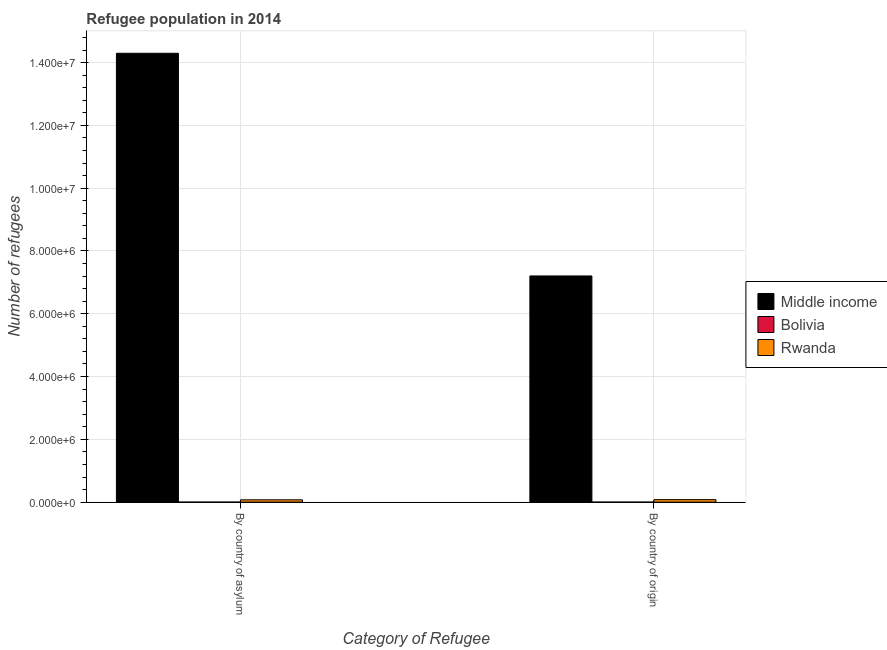How many different coloured bars are there?
Your response must be concise. 3. Are the number of bars per tick equal to the number of legend labels?
Provide a succinct answer. Yes. How many bars are there on the 1st tick from the right?
Provide a short and direct response. 3. What is the label of the 2nd group of bars from the left?
Offer a very short reply. By country of origin. What is the number of refugees by country of asylum in Rwanda?
Your response must be concise. 7.38e+04. Across all countries, what is the maximum number of refugees by country of origin?
Provide a succinct answer. 7.20e+06. Across all countries, what is the minimum number of refugees by country of asylum?
Your answer should be compact. 763. In which country was the number of refugees by country of origin minimum?
Your answer should be very brief. Bolivia. What is the total number of refugees by country of asylum in the graph?
Give a very brief answer. 1.44e+07. What is the difference between the number of refugees by country of origin in Bolivia and that in Middle income?
Your answer should be compact. -7.20e+06. What is the difference between the number of refugees by country of origin in Middle income and the number of refugees by country of asylum in Rwanda?
Keep it short and to the point. 7.13e+06. What is the average number of refugees by country of origin per country?
Ensure brevity in your answer.  2.43e+06. What is the difference between the number of refugees by country of asylum and number of refugees by country of origin in Bolivia?
Provide a short and direct response. 164. What is the ratio of the number of refugees by country of origin in Rwanda to that in Bolivia?
Give a very brief answer. 132.57. What does the 2nd bar from the left in By country of asylum represents?
Offer a terse response. Bolivia. How many bars are there?
Ensure brevity in your answer.  6. Are all the bars in the graph horizontal?
Your response must be concise. No. How many countries are there in the graph?
Make the answer very short. 3. What is the difference between two consecutive major ticks on the Y-axis?
Offer a very short reply. 2.00e+06. Does the graph contain grids?
Keep it short and to the point. Yes. How many legend labels are there?
Offer a terse response. 3. How are the legend labels stacked?
Your answer should be compact. Vertical. What is the title of the graph?
Keep it short and to the point. Refugee population in 2014. Does "Korea (Democratic)" appear as one of the legend labels in the graph?
Make the answer very short. No. What is the label or title of the X-axis?
Provide a succinct answer. Category of Refugee. What is the label or title of the Y-axis?
Offer a terse response. Number of refugees. What is the Number of refugees of Middle income in By country of asylum?
Provide a short and direct response. 1.43e+07. What is the Number of refugees in Bolivia in By country of asylum?
Provide a succinct answer. 763. What is the Number of refugees in Rwanda in By country of asylum?
Offer a very short reply. 7.38e+04. What is the Number of refugees in Middle income in By country of origin?
Offer a very short reply. 7.20e+06. What is the Number of refugees in Bolivia in By country of origin?
Your response must be concise. 599. What is the Number of refugees in Rwanda in By country of origin?
Your answer should be very brief. 7.94e+04. Across all Category of Refugee, what is the maximum Number of refugees in Middle income?
Offer a terse response. 1.43e+07. Across all Category of Refugee, what is the maximum Number of refugees in Bolivia?
Your answer should be very brief. 763. Across all Category of Refugee, what is the maximum Number of refugees in Rwanda?
Your response must be concise. 7.94e+04. Across all Category of Refugee, what is the minimum Number of refugees in Middle income?
Provide a succinct answer. 7.20e+06. Across all Category of Refugee, what is the minimum Number of refugees in Bolivia?
Your answer should be compact. 599. Across all Category of Refugee, what is the minimum Number of refugees in Rwanda?
Provide a short and direct response. 7.38e+04. What is the total Number of refugees of Middle income in the graph?
Make the answer very short. 2.15e+07. What is the total Number of refugees in Bolivia in the graph?
Keep it short and to the point. 1362. What is the total Number of refugees of Rwanda in the graph?
Provide a short and direct response. 1.53e+05. What is the difference between the Number of refugees of Middle income in By country of asylum and that in By country of origin?
Provide a succinct answer. 7.09e+06. What is the difference between the Number of refugees of Bolivia in By country of asylum and that in By country of origin?
Your answer should be very brief. 164. What is the difference between the Number of refugees of Rwanda in By country of asylum and that in By country of origin?
Offer a very short reply. -5591. What is the difference between the Number of refugees of Middle income in By country of asylum and the Number of refugees of Bolivia in By country of origin?
Your answer should be compact. 1.43e+07. What is the difference between the Number of refugees in Middle income in By country of asylum and the Number of refugees in Rwanda in By country of origin?
Give a very brief answer. 1.42e+07. What is the difference between the Number of refugees of Bolivia in By country of asylum and the Number of refugees of Rwanda in By country of origin?
Offer a terse response. -7.86e+04. What is the average Number of refugees of Middle income per Category of Refugee?
Keep it short and to the point. 1.08e+07. What is the average Number of refugees of Bolivia per Category of Refugee?
Make the answer very short. 681. What is the average Number of refugees in Rwanda per Category of Refugee?
Offer a very short reply. 7.66e+04. What is the difference between the Number of refugees of Middle income and Number of refugees of Bolivia in By country of asylum?
Give a very brief answer. 1.43e+07. What is the difference between the Number of refugees in Middle income and Number of refugees in Rwanda in By country of asylum?
Give a very brief answer. 1.42e+07. What is the difference between the Number of refugees in Bolivia and Number of refugees in Rwanda in By country of asylum?
Ensure brevity in your answer.  -7.31e+04. What is the difference between the Number of refugees of Middle income and Number of refugees of Bolivia in By country of origin?
Make the answer very short. 7.20e+06. What is the difference between the Number of refugees in Middle income and Number of refugees in Rwanda in By country of origin?
Give a very brief answer. 7.13e+06. What is the difference between the Number of refugees of Bolivia and Number of refugees of Rwanda in By country of origin?
Provide a short and direct response. -7.88e+04. What is the ratio of the Number of refugees of Middle income in By country of asylum to that in By country of origin?
Offer a very short reply. 1.98. What is the ratio of the Number of refugees in Bolivia in By country of asylum to that in By country of origin?
Offer a terse response. 1.27. What is the ratio of the Number of refugees of Rwanda in By country of asylum to that in By country of origin?
Ensure brevity in your answer.  0.93. What is the difference between the highest and the second highest Number of refugees of Middle income?
Offer a very short reply. 7.09e+06. What is the difference between the highest and the second highest Number of refugees of Bolivia?
Your response must be concise. 164. What is the difference between the highest and the second highest Number of refugees in Rwanda?
Offer a very short reply. 5591. What is the difference between the highest and the lowest Number of refugees of Middle income?
Provide a short and direct response. 7.09e+06. What is the difference between the highest and the lowest Number of refugees in Bolivia?
Your response must be concise. 164. What is the difference between the highest and the lowest Number of refugees of Rwanda?
Your response must be concise. 5591. 